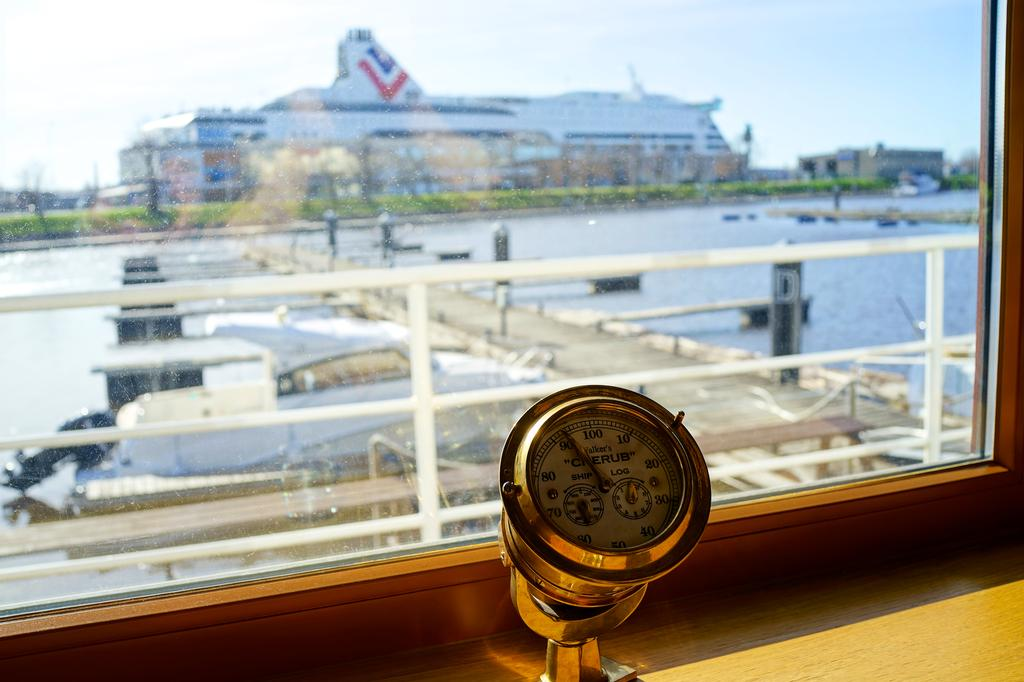<image>
Give a short and clear explanation of the subsequent image. A dial reads "Walker's Cherub" and has numbers from 10 to 100 on it. 